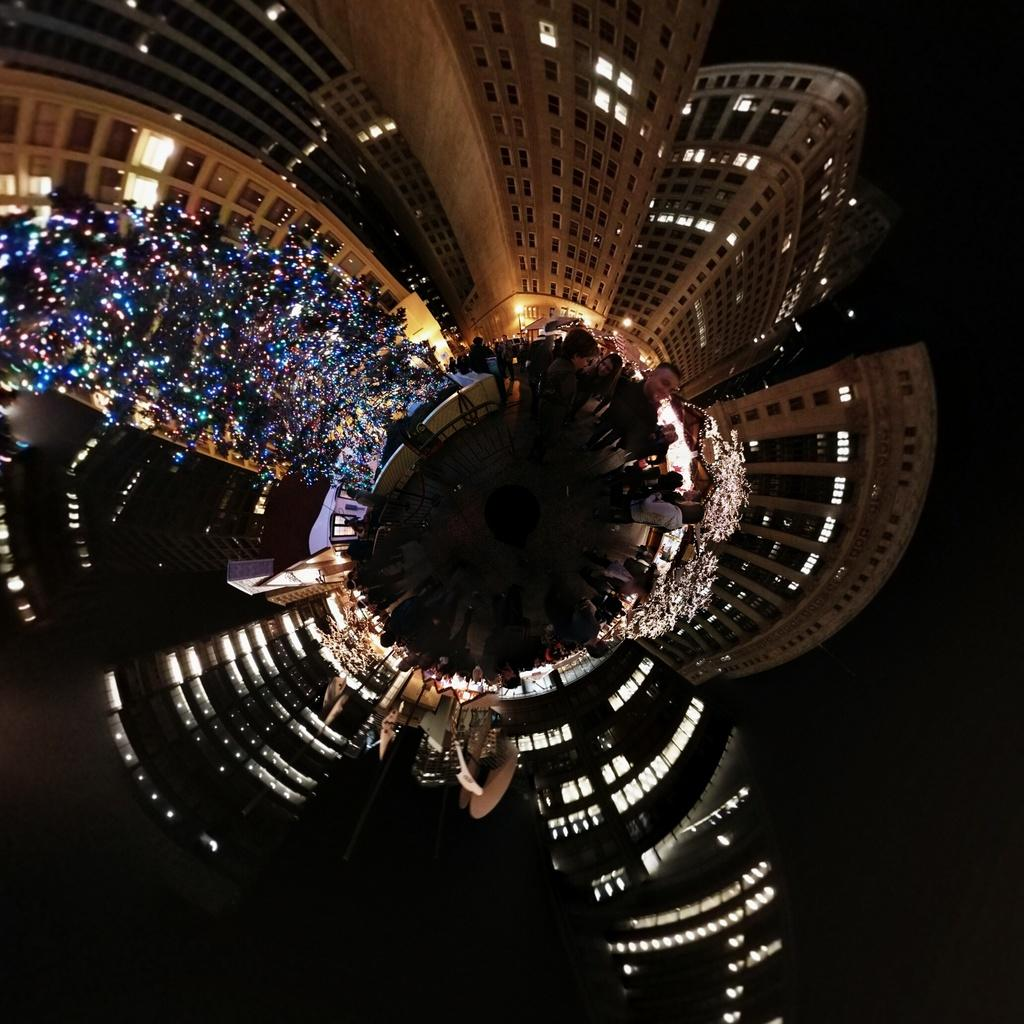What type of structures are illuminated in the image? There are buildings with lights in the image. What else in the image has lights? There is an object that looks like a tree with lights. Can you describe the people visible in the image? Unfortunately, the image does not provide enough detail to describe the people. How many plants are being transported by ants in the image? There are no plants or ants present in the image. 